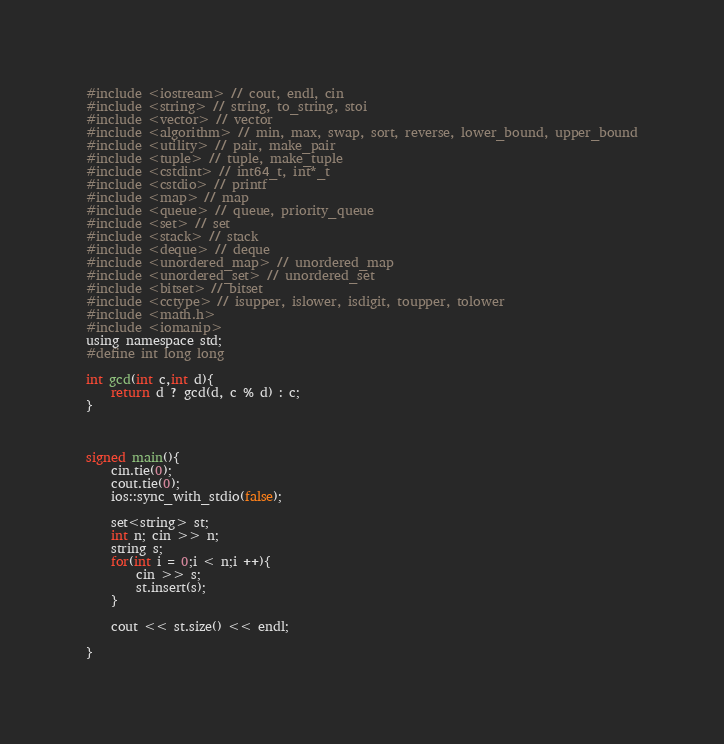Convert code to text. <code><loc_0><loc_0><loc_500><loc_500><_C_>#include <iostream> // cout, endl, cin
#include <string> // string, to_string, stoi
#include <vector> // vector
#include <algorithm> // min, max, swap, sort, reverse, lower_bound, upper_bound
#include <utility> // pair, make_pair
#include <tuple> // tuple, make_tuple
#include <cstdint> // int64_t, int*_t
#include <cstdio> // printf
#include <map> // map
#include <queue> // queue, priority_queue
#include <set> // set
#include <stack> // stack
#include <deque> // deque
#include <unordered_map> // unordered_map
#include <unordered_set> // unordered_set
#include <bitset> // bitset
#include <cctype> // isupper, islower, isdigit, toupper, tolower
#include <math.h>
#include <iomanip>
using namespace std;
#define int long long

int gcd(int c,int d){
    return d ? gcd(d, c % d) : c;
}



signed main(){
    cin.tie(0);
    cout.tie(0);
    ios::sync_with_stdio(false);

    set<string> st;
    int n; cin >> n;
    string s;
    for(int i = 0;i < n;i ++){
        cin >> s;
        st.insert(s);
    }

    cout << st.size() << endl;

}

</code> 